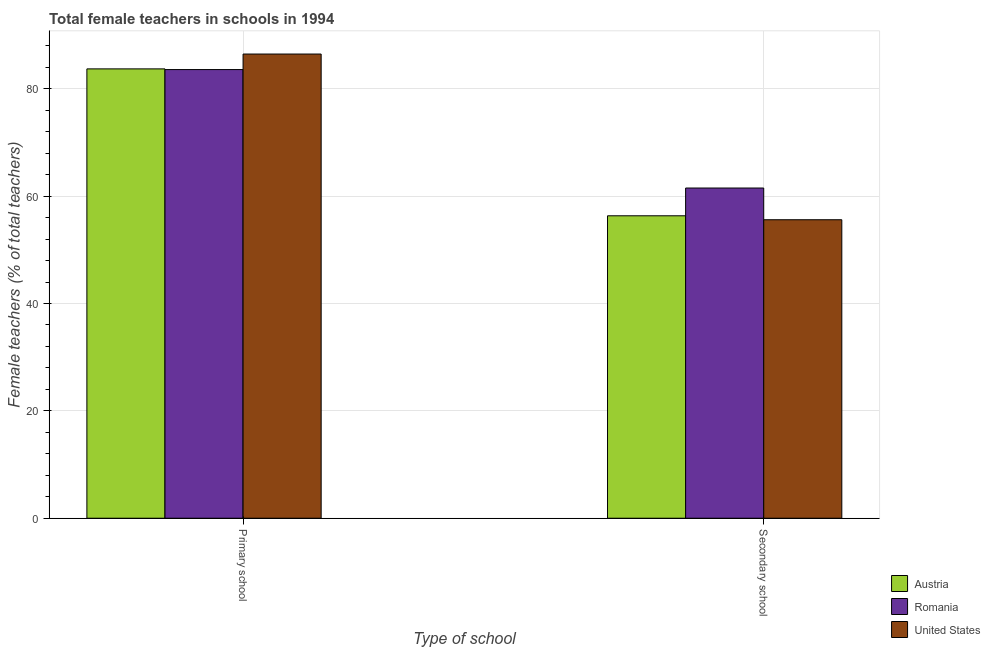How many different coloured bars are there?
Offer a terse response. 3. How many bars are there on the 1st tick from the left?
Give a very brief answer. 3. How many bars are there on the 2nd tick from the right?
Provide a succinct answer. 3. What is the label of the 2nd group of bars from the left?
Ensure brevity in your answer.  Secondary school. What is the percentage of female teachers in secondary schools in United States?
Offer a terse response. 55.61. Across all countries, what is the maximum percentage of female teachers in secondary schools?
Your answer should be very brief. 61.52. Across all countries, what is the minimum percentage of female teachers in secondary schools?
Keep it short and to the point. 55.61. In which country was the percentage of female teachers in secondary schools maximum?
Give a very brief answer. Romania. In which country was the percentage of female teachers in primary schools minimum?
Ensure brevity in your answer.  Romania. What is the total percentage of female teachers in secondary schools in the graph?
Your response must be concise. 173.47. What is the difference between the percentage of female teachers in primary schools in Romania and that in United States?
Provide a succinct answer. -2.89. What is the difference between the percentage of female teachers in primary schools in Romania and the percentage of female teachers in secondary schools in United States?
Your answer should be very brief. 27.98. What is the average percentage of female teachers in secondary schools per country?
Your answer should be very brief. 57.82. What is the difference between the percentage of female teachers in primary schools and percentage of female teachers in secondary schools in Romania?
Offer a terse response. 22.07. In how many countries, is the percentage of female teachers in primary schools greater than 16 %?
Your response must be concise. 3. What is the ratio of the percentage of female teachers in secondary schools in United States to that in Austria?
Ensure brevity in your answer.  0.99. What does the 3rd bar from the left in Primary school represents?
Your answer should be very brief. United States. How many bars are there?
Offer a very short reply. 6. Are all the bars in the graph horizontal?
Provide a short and direct response. No. What is the difference between two consecutive major ticks on the Y-axis?
Offer a terse response. 20. Does the graph contain grids?
Ensure brevity in your answer.  Yes. Where does the legend appear in the graph?
Provide a short and direct response. Bottom right. How many legend labels are there?
Ensure brevity in your answer.  3. What is the title of the graph?
Offer a terse response. Total female teachers in schools in 1994. What is the label or title of the X-axis?
Offer a terse response. Type of school. What is the label or title of the Y-axis?
Ensure brevity in your answer.  Female teachers (% of total teachers). What is the Female teachers (% of total teachers) in Austria in Primary school?
Give a very brief answer. 83.71. What is the Female teachers (% of total teachers) of Romania in Primary school?
Offer a very short reply. 83.58. What is the Female teachers (% of total teachers) in United States in Primary school?
Your answer should be compact. 86.48. What is the Female teachers (% of total teachers) in Austria in Secondary school?
Ensure brevity in your answer.  56.34. What is the Female teachers (% of total teachers) in Romania in Secondary school?
Provide a succinct answer. 61.52. What is the Female teachers (% of total teachers) in United States in Secondary school?
Ensure brevity in your answer.  55.61. Across all Type of school, what is the maximum Female teachers (% of total teachers) in Austria?
Give a very brief answer. 83.71. Across all Type of school, what is the maximum Female teachers (% of total teachers) in Romania?
Provide a succinct answer. 83.58. Across all Type of school, what is the maximum Female teachers (% of total teachers) of United States?
Offer a very short reply. 86.48. Across all Type of school, what is the minimum Female teachers (% of total teachers) of Austria?
Your answer should be compact. 56.34. Across all Type of school, what is the minimum Female teachers (% of total teachers) in Romania?
Your response must be concise. 61.52. Across all Type of school, what is the minimum Female teachers (% of total teachers) in United States?
Offer a terse response. 55.61. What is the total Female teachers (% of total teachers) of Austria in the graph?
Ensure brevity in your answer.  140.06. What is the total Female teachers (% of total teachers) in Romania in the graph?
Your answer should be very brief. 145.1. What is the total Female teachers (% of total teachers) of United States in the graph?
Your answer should be compact. 142.09. What is the difference between the Female teachers (% of total teachers) of Austria in Primary school and that in Secondary school?
Provide a succinct answer. 27.37. What is the difference between the Female teachers (% of total teachers) in Romania in Primary school and that in Secondary school?
Offer a very short reply. 22.07. What is the difference between the Female teachers (% of total teachers) of United States in Primary school and that in Secondary school?
Provide a short and direct response. 30.87. What is the difference between the Female teachers (% of total teachers) of Austria in Primary school and the Female teachers (% of total teachers) of Romania in Secondary school?
Keep it short and to the point. 22.2. What is the difference between the Female teachers (% of total teachers) of Austria in Primary school and the Female teachers (% of total teachers) of United States in Secondary school?
Provide a succinct answer. 28.11. What is the difference between the Female teachers (% of total teachers) in Romania in Primary school and the Female teachers (% of total teachers) in United States in Secondary school?
Your response must be concise. 27.98. What is the average Female teachers (% of total teachers) in Austria per Type of school?
Offer a terse response. 70.03. What is the average Female teachers (% of total teachers) of Romania per Type of school?
Your response must be concise. 72.55. What is the average Female teachers (% of total teachers) of United States per Type of school?
Offer a very short reply. 71.04. What is the difference between the Female teachers (% of total teachers) in Austria and Female teachers (% of total teachers) in Romania in Primary school?
Your response must be concise. 0.13. What is the difference between the Female teachers (% of total teachers) of Austria and Female teachers (% of total teachers) of United States in Primary school?
Your answer should be compact. -2.76. What is the difference between the Female teachers (% of total teachers) in Romania and Female teachers (% of total teachers) in United States in Primary school?
Provide a succinct answer. -2.89. What is the difference between the Female teachers (% of total teachers) in Austria and Female teachers (% of total teachers) in Romania in Secondary school?
Keep it short and to the point. -5.17. What is the difference between the Female teachers (% of total teachers) in Austria and Female teachers (% of total teachers) in United States in Secondary school?
Make the answer very short. 0.73. What is the difference between the Female teachers (% of total teachers) in Romania and Female teachers (% of total teachers) in United States in Secondary school?
Provide a short and direct response. 5.91. What is the ratio of the Female teachers (% of total teachers) in Austria in Primary school to that in Secondary school?
Your answer should be compact. 1.49. What is the ratio of the Female teachers (% of total teachers) of Romania in Primary school to that in Secondary school?
Offer a very short reply. 1.36. What is the ratio of the Female teachers (% of total teachers) in United States in Primary school to that in Secondary school?
Keep it short and to the point. 1.56. What is the difference between the highest and the second highest Female teachers (% of total teachers) in Austria?
Your response must be concise. 27.37. What is the difference between the highest and the second highest Female teachers (% of total teachers) in Romania?
Your answer should be very brief. 22.07. What is the difference between the highest and the second highest Female teachers (% of total teachers) of United States?
Your answer should be compact. 30.87. What is the difference between the highest and the lowest Female teachers (% of total teachers) in Austria?
Provide a short and direct response. 27.37. What is the difference between the highest and the lowest Female teachers (% of total teachers) in Romania?
Keep it short and to the point. 22.07. What is the difference between the highest and the lowest Female teachers (% of total teachers) of United States?
Offer a very short reply. 30.87. 